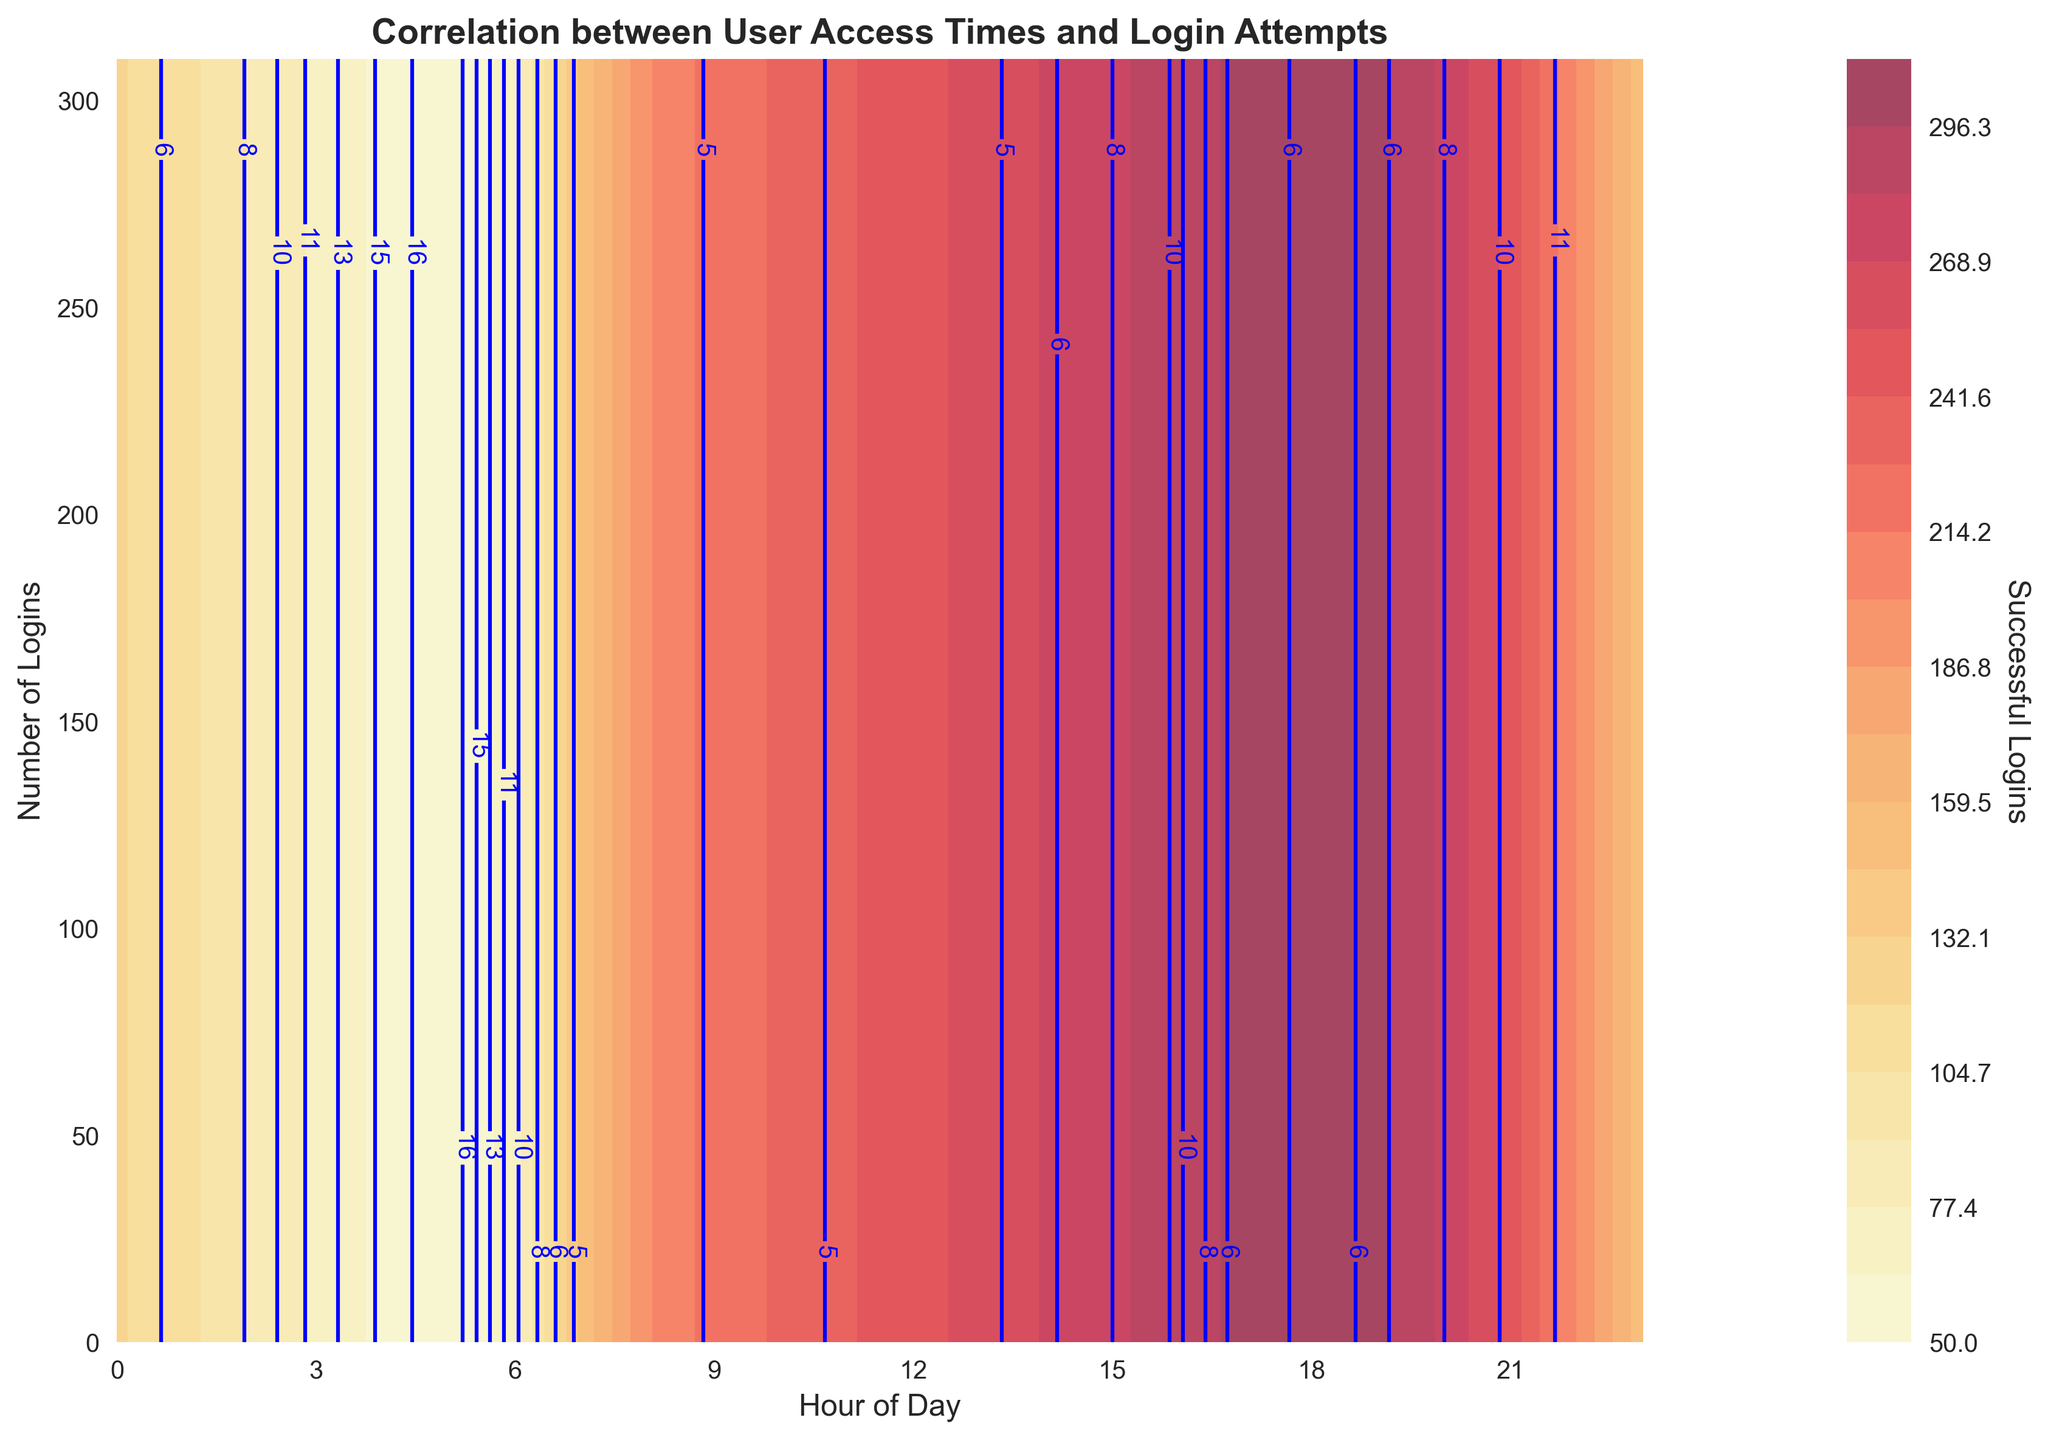How does the number of successful logins change over the hours of the day? The number of successful logins generally increases throughout the day, starting at around 50 in the early morning hours and peaking at 310 around 18:00. It then gradually decreases into the late evening.
Answer: Increases then decreases What is the maximum number of successful logins indicated on the plot? The contour plot and labels show the maximum number of successful logins occurring at 18:00, where it reaches 310.
Answer: 310 During which hours do the successful logins range between 250 and 300? Observing the contour levels, successful logins range between 250 and 300 mostly from 12:00 to 17:00 and briefly again at 19:00 and 20:00.
Answer: 12:00-17:00, 19:00, 20:00 How do the numbers of unsuccessful logins compare at 3:00 and 22:00? By comparing the contour labels at 3:00 and 22:00, the number of unsuccessful logins at 3:00 is 12, while at 22:00 it is slightly higher at 12.
Answer: 3:00: 12, 22:00: 12 Which hour has the lowest number of both successful and unsuccessful logins? The lowest successful logins are around 50 at 5:00, and the lowest unsuccessful logins are around 3 at 8:00 and 12:00. There is no single hour with the lowest of both.
Answer: Different hours What does the blue contour line represent in the plot? The blue contour lines represent levels of unsuccessful login attempts, with each line indicating a different number of unsuccessful logins.
Answer: Unsuccessful logins At what time does the number of successful logins start to decrease significantly? Analyzing the trend, the number of successful logins starts to decrease significantly around 20:00 after peaking around 18:00.
Answer: 20:00 Is there a correlation between the number of successful and unsuccessful logins? From the contour plot, both successful and unsuccessful logins somewhat follow similar patterns, increasing during work hours and decreasing at night, indicating some correlation.
Answer: Yes, some correlation What is the range of the contour levels used for successful and unsuccessful logins? The contour levels range from 50 to 310 for successful logins and 3 to 18 for unsuccessful logins.
Answer: 50-310 and 3-18 How do the number of successful and unsuccessful logins relate at around 10:00? At 10:00, the contour plot indicates approximately 230 successful logins and around 6 unsuccessful logins.
Answer: 230 successful, 6 unsuccessful 